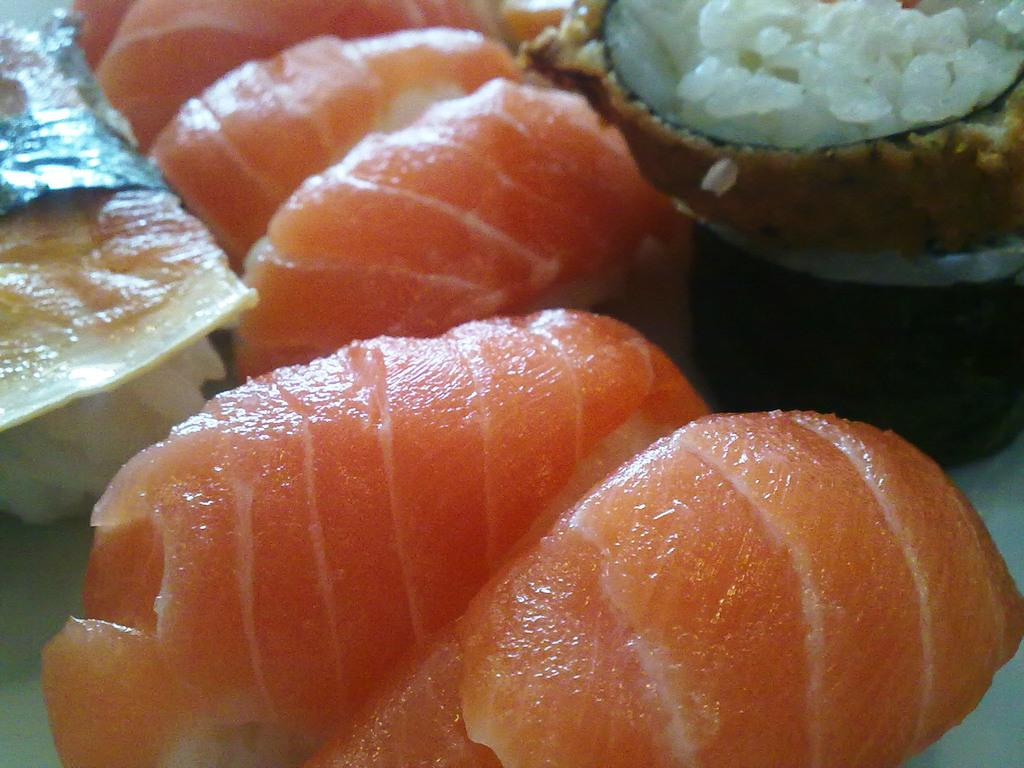What can be seen in the image? There is food in the image. Can you describe the food in the image? Unfortunately, the facts provided do not give specific details about the food. Is there any context or setting that can be observed in the image? The facts provided do not give any information about the context or setting of the image. What type of jar is being used to store the experience in the image? There is no mention of a jar or an experience in the image. The image only contains food. 